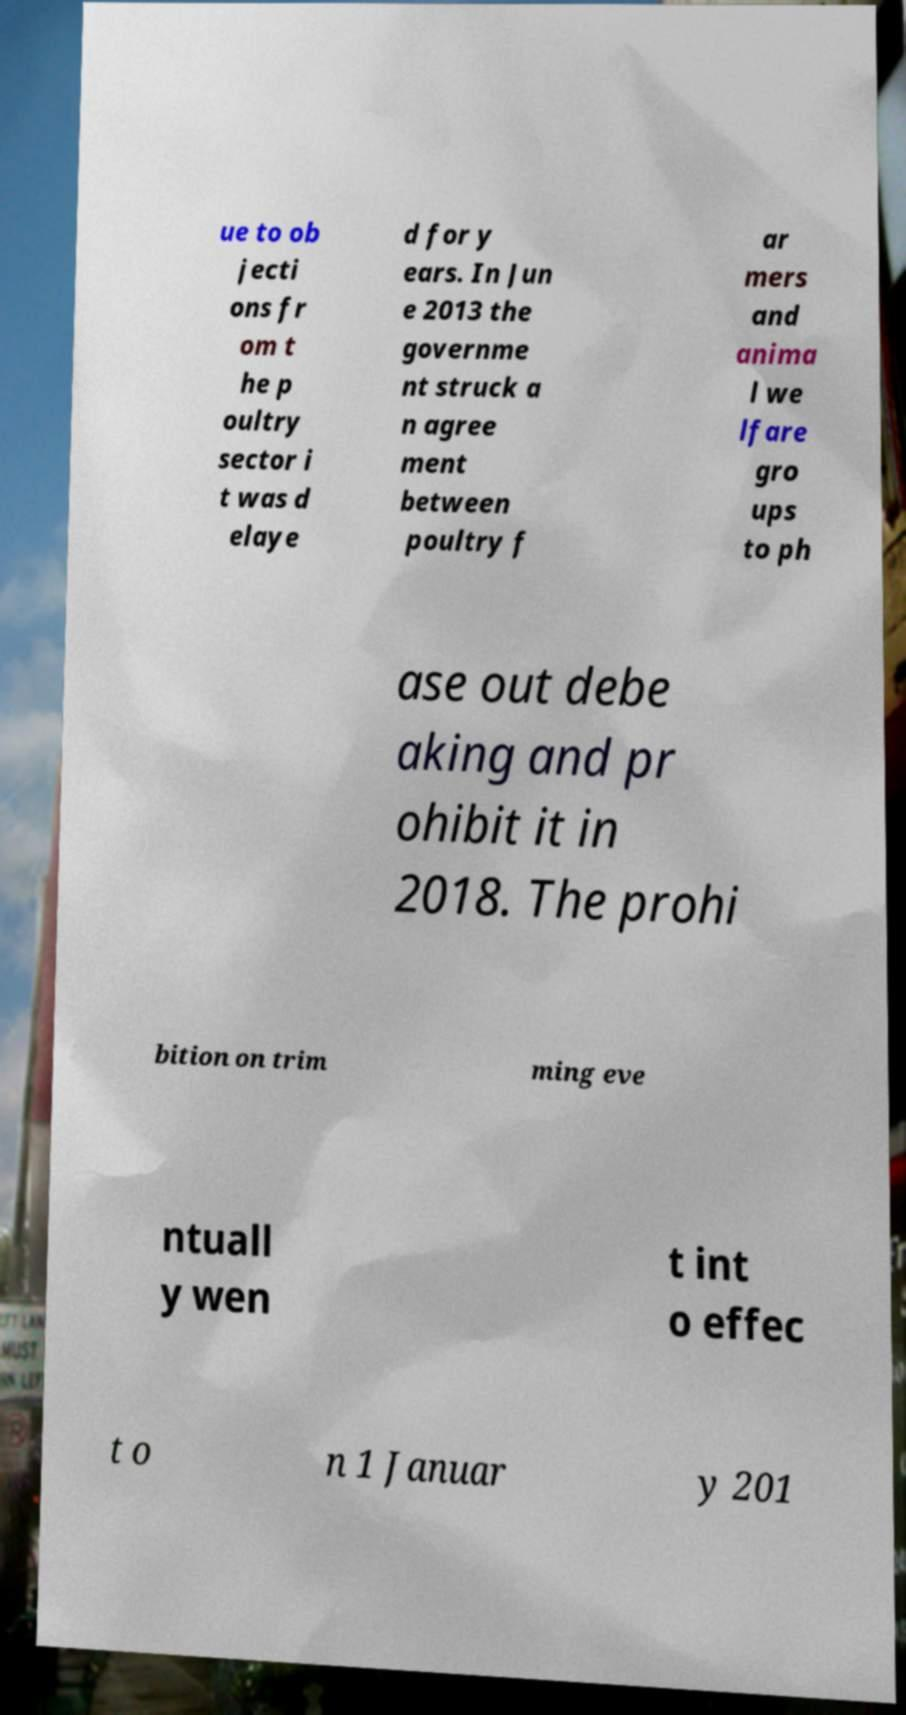Can you read and provide the text displayed in the image?This photo seems to have some interesting text. Can you extract and type it out for me? ue to ob jecti ons fr om t he p oultry sector i t was d elaye d for y ears. In Jun e 2013 the governme nt struck a n agree ment between poultry f ar mers and anima l we lfare gro ups to ph ase out debe aking and pr ohibit it in 2018. The prohi bition on trim ming eve ntuall y wen t int o effec t o n 1 Januar y 201 